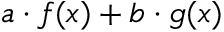Convert formula to latex. <formula><loc_0><loc_0><loc_500><loc_500>a \cdot f ( x ) + b \cdot g ( x )</formula> 